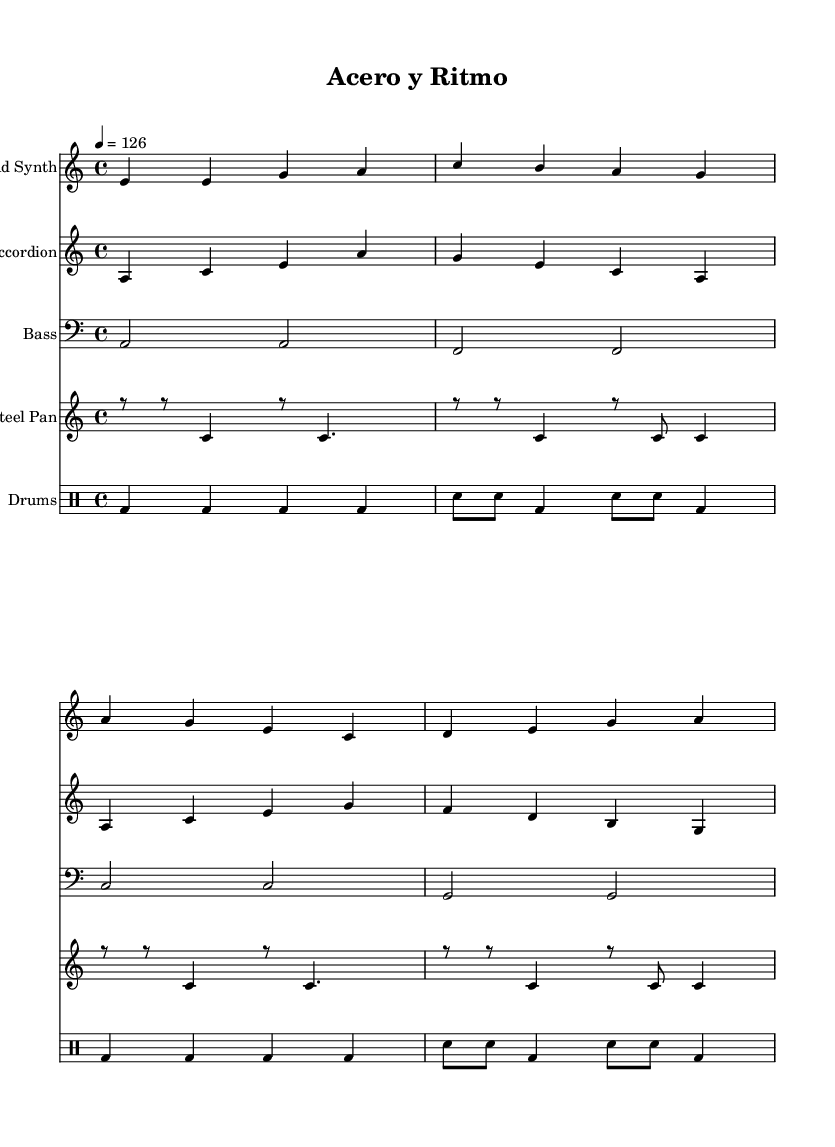What is the key signature of this music? The key signature is A minor, which is indicated by one sharp (G#) when viewing the note on the staff. The absence of sharps or flats in the notation confirms it is a natural minor scale.
Answer: A minor What is the time signature of this piece? The time signature is 4/4, which can be identified at the beginning of the score with the "4/4" marking. This indicates there are four beats in each measure, and a quarter note receives one beat.
Answer: 4/4 What is the tempo marking for this music? The tempo marking is 126 beats per minute, as noted at the beginning of the score with "4 = 126," which indicates how fast the piece should be played.
Answer: 126 Which instruments are being used in this piece? The instruments shown include Lead Synth, Accordion, Bass, Steel Pan, and Drums. The staff names at the beginning of each section show the names of the respective instruments used for this composition.
Answer: Lead Synth, Accordion, Bass, Steel Pan, Drums What type of percussion elements are present in this score? The percussion elements include bass drum and snare drum, indicated by the "bd" and "sn" markings in the drum staff under the drummode section, confirming the style of beat and rhythm typical for house music.
Answer: Bass drum, Snare drum How many measures are there in the lead synth part? The lead synth part consists of four measures, which can be counted by looking for the vertical bar lines that separate different measures within the music notation.
Answer: Four What is the primary melodic instrument in this piece? The primary melodic instrument is the Lead Synth, as it carries the main melody, indicated by its placement and the detailing in the first staff of the score.
Answer: Lead Synth 